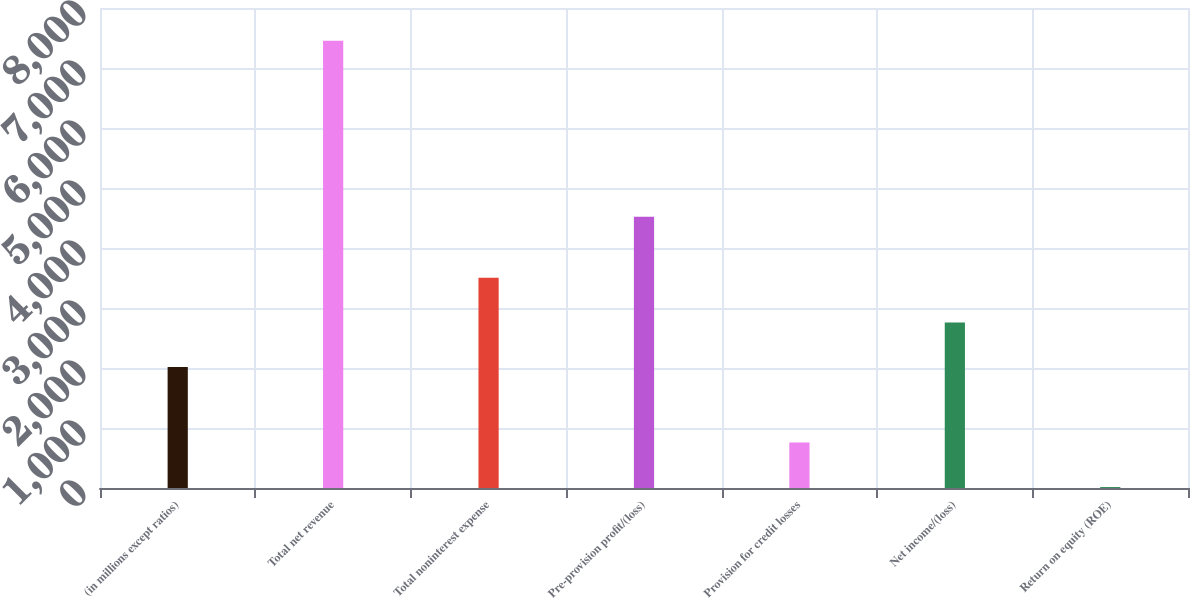<chart> <loc_0><loc_0><loc_500><loc_500><bar_chart><fcel>(in millions except ratios)<fcel>Total net revenue<fcel>Total noninterest expense<fcel>Pre-provision profit/(loss)<fcel>Provision for credit losses<fcel>Net income/(loss)<fcel>Return on equity (ROE)<nl><fcel>2016<fcel>7453<fcel>3503.4<fcel>4519<fcel>759.7<fcel>2759.7<fcel>16<nl></chart> 